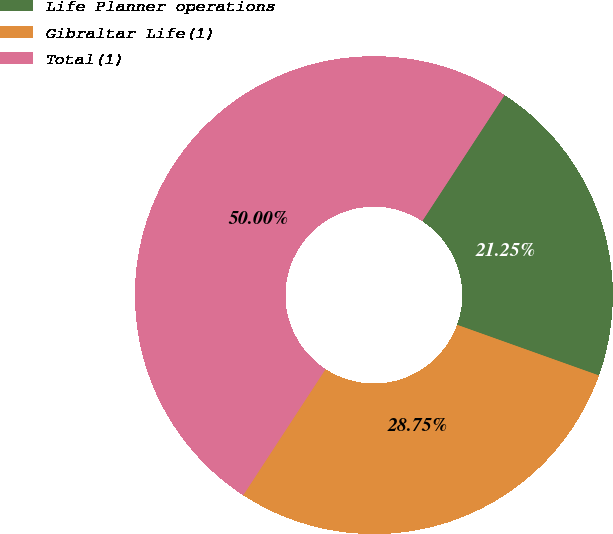<chart> <loc_0><loc_0><loc_500><loc_500><pie_chart><fcel>Life Planner operations<fcel>Gibraltar Life(1)<fcel>Total(1)<nl><fcel>21.25%<fcel>28.75%<fcel>50.0%<nl></chart> 